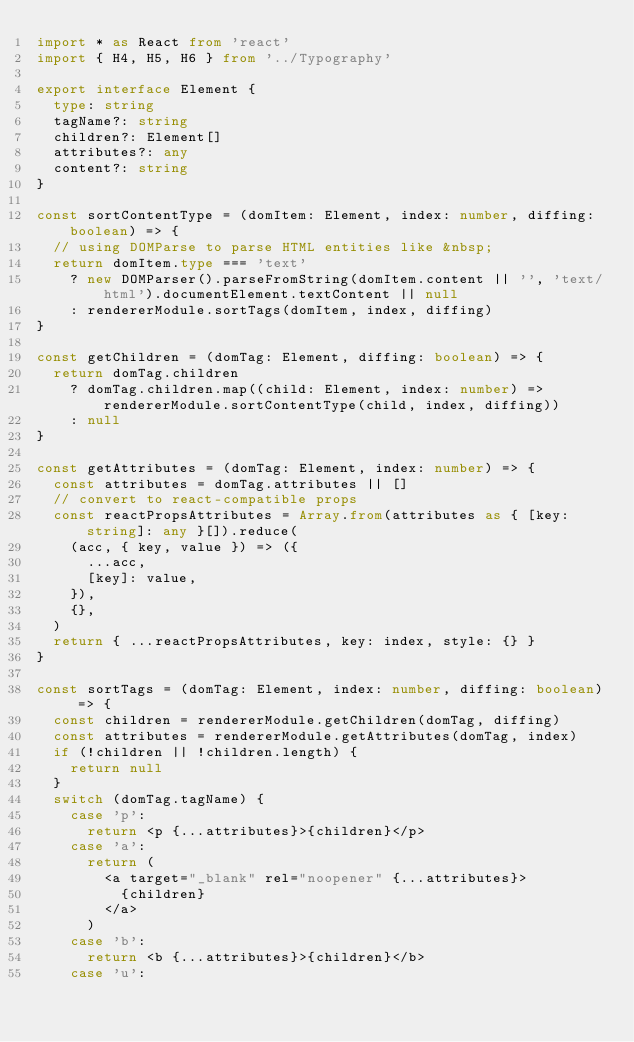Convert code to text. <code><loc_0><loc_0><loc_500><loc_500><_TypeScript_>import * as React from 'react'
import { H4, H5, H6 } from '../Typography'

export interface Element {
  type: string
  tagName?: string
  children?: Element[]
  attributes?: any
  content?: string
}

const sortContentType = (domItem: Element, index: number, diffing: boolean) => {
  // using DOMParse to parse HTML entities like &nbsp;
  return domItem.type === 'text'
    ? new DOMParser().parseFromString(domItem.content || '', 'text/html').documentElement.textContent || null
    : rendererModule.sortTags(domItem, index, diffing)
}

const getChildren = (domTag: Element, diffing: boolean) => {
  return domTag.children
    ? domTag.children.map((child: Element, index: number) => rendererModule.sortContentType(child, index, diffing))
    : null
}

const getAttributes = (domTag: Element, index: number) => {
  const attributes = domTag.attributes || []
  // convert to react-compatible props
  const reactPropsAttributes = Array.from(attributes as { [key: string]: any }[]).reduce(
    (acc, { key, value }) => ({
      ...acc,
      [key]: value,
    }),
    {},
  )
  return { ...reactPropsAttributes, key: index, style: {} }
}

const sortTags = (domTag: Element, index: number, diffing: boolean) => {
  const children = rendererModule.getChildren(domTag, diffing)
  const attributes = rendererModule.getAttributes(domTag, index)
  if (!children || !children.length) {
    return null
  }
  switch (domTag.tagName) {
    case 'p':
      return <p {...attributes}>{children}</p>
    case 'a':
      return (
        <a target="_blank" rel="noopener" {...attributes}>
          {children}
        </a>
      )
    case 'b':
      return <b {...attributes}>{children}</b>
    case 'u':</code> 